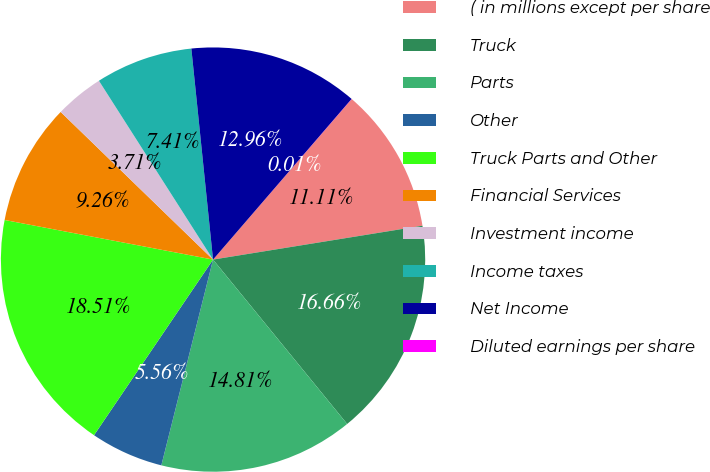Convert chart to OTSL. <chart><loc_0><loc_0><loc_500><loc_500><pie_chart><fcel>( in millions except per share<fcel>Truck<fcel>Parts<fcel>Other<fcel>Truck Parts and Other<fcel>Financial Services<fcel>Investment income<fcel>Income taxes<fcel>Net Income<fcel>Diluted earnings per share<nl><fcel>11.11%<fcel>16.66%<fcel>14.81%<fcel>5.56%<fcel>18.51%<fcel>9.26%<fcel>3.71%<fcel>7.41%<fcel>12.96%<fcel>0.01%<nl></chart> 